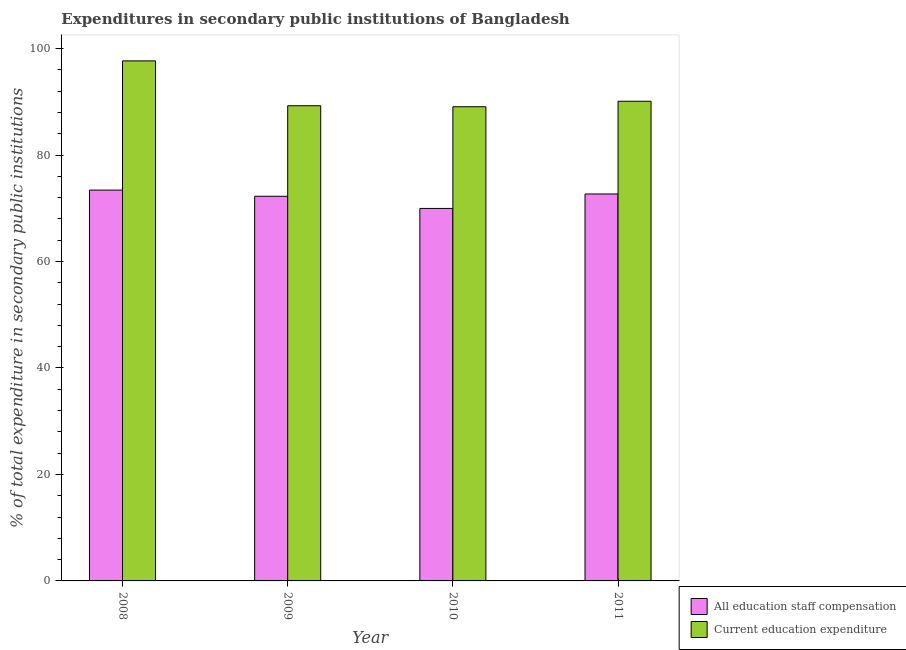Are the number of bars per tick equal to the number of legend labels?
Offer a very short reply. Yes. How many bars are there on the 2nd tick from the left?
Offer a very short reply. 2. What is the label of the 4th group of bars from the left?
Your answer should be compact. 2011. In how many cases, is the number of bars for a given year not equal to the number of legend labels?
Ensure brevity in your answer.  0. What is the expenditure in staff compensation in 2011?
Provide a short and direct response. 72.69. Across all years, what is the maximum expenditure in education?
Provide a short and direct response. 97.69. Across all years, what is the minimum expenditure in education?
Offer a very short reply. 89.08. In which year was the expenditure in staff compensation maximum?
Offer a terse response. 2008. In which year was the expenditure in staff compensation minimum?
Your answer should be very brief. 2010. What is the total expenditure in education in the graph?
Provide a succinct answer. 366.15. What is the difference between the expenditure in education in 2009 and that in 2010?
Provide a short and direct response. 0.19. What is the difference between the expenditure in education in 2010 and the expenditure in staff compensation in 2009?
Your response must be concise. -0.19. What is the average expenditure in education per year?
Offer a terse response. 91.54. In the year 2009, what is the difference between the expenditure in education and expenditure in staff compensation?
Ensure brevity in your answer.  0. What is the ratio of the expenditure in education in 2008 to that in 2011?
Keep it short and to the point. 1.08. Is the expenditure in staff compensation in 2010 less than that in 2011?
Provide a short and direct response. Yes. What is the difference between the highest and the second highest expenditure in staff compensation?
Offer a terse response. 0.73. What is the difference between the highest and the lowest expenditure in staff compensation?
Keep it short and to the point. 3.44. What does the 1st bar from the left in 2008 represents?
Provide a succinct answer. All education staff compensation. What does the 1st bar from the right in 2011 represents?
Give a very brief answer. Current education expenditure. How many bars are there?
Offer a terse response. 8. Are all the bars in the graph horizontal?
Give a very brief answer. No. How many years are there in the graph?
Provide a short and direct response. 4. What is the difference between two consecutive major ticks on the Y-axis?
Keep it short and to the point. 20. How many legend labels are there?
Keep it short and to the point. 2. What is the title of the graph?
Your answer should be very brief. Expenditures in secondary public institutions of Bangladesh. Does "From human activities" appear as one of the legend labels in the graph?
Your response must be concise. No. What is the label or title of the X-axis?
Ensure brevity in your answer.  Year. What is the label or title of the Y-axis?
Make the answer very short. % of total expenditure in secondary public institutions. What is the % of total expenditure in secondary public institutions of All education staff compensation in 2008?
Provide a short and direct response. 73.42. What is the % of total expenditure in secondary public institutions of Current education expenditure in 2008?
Offer a very short reply. 97.69. What is the % of total expenditure in secondary public institutions in All education staff compensation in 2009?
Provide a short and direct response. 72.26. What is the % of total expenditure in secondary public institutions of Current education expenditure in 2009?
Your answer should be very brief. 89.26. What is the % of total expenditure in secondary public institutions of All education staff compensation in 2010?
Offer a very short reply. 69.97. What is the % of total expenditure in secondary public institutions of Current education expenditure in 2010?
Offer a terse response. 89.08. What is the % of total expenditure in secondary public institutions of All education staff compensation in 2011?
Provide a succinct answer. 72.69. What is the % of total expenditure in secondary public institutions in Current education expenditure in 2011?
Offer a very short reply. 90.11. Across all years, what is the maximum % of total expenditure in secondary public institutions in All education staff compensation?
Provide a short and direct response. 73.42. Across all years, what is the maximum % of total expenditure in secondary public institutions of Current education expenditure?
Provide a short and direct response. 97.69. Across all years, what is the minimum % of total expenditure in secondary public institutions of All education staff compensation?
Your response must be concise. 69.97. Across all years, what is the minimum % of total expenditure in secondary public institutions in Current education expenditure?
Ensure brevity in your answer.  89.08. What is the total % of total expenditure in secondary public institutions in All education staff compensation in the graph?
Give a very brief answer. 288.34. What is the total % of total expenditure in secondary public institutions in Current education expenditure in the graph?
Give a very brief answer. 366.15. What is the difference between the % of total expenditure in secondary public institutions in All education staff compensation in 2008 and that in 2009?
Your answer should be compact. 1.16. What is the difference between the % of total expenditure in secondary public institutions of Current education expenditure in 2008 and that in 2009?
Your answer should be very brief. 8.43. What is the difference between the % of total expenditure in secondary public institutions in All education staff compensation in 2008 and that in 2010?
Offer a very short reply. 3.44. What is the difference between the % of total expenditure in secondary public institutions of Current education expenditure in 2008 and that in 2010?
Your response must be concise. 8.62. What is the difference between the % of total expenditure in secondary public institutions of All education staff compensation in 2008 and that in 2011?
Give a very brief answer. 0.73. What is the difference between the % of total expenditure in secondary public institutions of Current education expenditure in 2008 and that in 2011?
Offer a terse response. 7.58. What is the difference between the % of total expenditure in secondary public institutions of All education staff compensation in 2009 and that in 2010?
Make the answer very short. 2.29. What is the difference between the % of total expenditure in secondary public institutions of Current education expenditure in 2009 and that in 2010?
Your answer should be compact. 0.19. What is the difference between the % of total expenditure in secondary public institutions in All education staff compensation in 2009 and that in 2011?
Ensure brevity in your answer.  -0.43. What is the difference between the % of total expenditure in secondary public institutions of Current education expenditure in 2009 and that in 2011?
Your answer should be very brief. -0.84. What is the difference between the % of total expenditure in secondary public institutions in All education staff compensation in 2010 and that in 2011?
Your response must be concise. -2.72. What is the difference between the % of total expenditure in secondary public institutions in Current education expenditure in 2010 and that in 2011?
Offer a very short reply. -1.03. What is the difference between the % of total expenditure in secondary public institutions in All education staff compensation in 2008 and the % of total expenditure in secondary public institutions in Current education expenditure in 2009?
Provide a succinct answer. -15.85. What is the difference between the % of total expenditure in secondary public institutions in All education staff compensation in 2008 and the % of total expenditure in secondary public institutions in Current education expenditure in 2010?
Offer a terse response. -15.66. What is the difference between the % of total expenditure in secondary public institutions in All education staff compensation in 2008 and the % of total expenditure in secondary public institutions in Current education expenditure in 2011?
Provide a short and direct response. -16.69. What is the difference between the % of total expenditure in secondary public institutions of All education staff compensation in 2009 and the % of total expenditure in secondary public institutions of Current education expenditure in 2010?
Provide a succinct answer. -16.82. What is the difference between the % of total expenditure in secondary public institutions of All education staff compensation in 2009 and the % of total expenditure in secondary public institutions of Current education expenditure in 2011?
Ensure brevity in your answer.  -17.85. What is the difference between the % of total expenditure in secondary public institutions in All education staff compensation in 2010 and the % of total expenditure in secondary public institutions in Current education expenditure in 2011?
Offer a very short reply. -20.13. What is the average % of total expenditure in secondary public institutions of All education staff compensation per year?
Provide a succinct answer. 72.09. What is the average % of total expenditure in secondary public institutions of Current education expenditure per year?
Offer a terse response. 91.54. In the year 2008, what is the difference between the % of total expenditure in secondary public institutions in All education staff compensation and % of total expenditure in secondary public institutions in Current education expenditure?
Make the answer very short. -24.28. In the year 2009, what is the difference between the % of total expenditure in secondary public institutions of All education staff compensation and % of total expenditure in secondary public institutions of Current education expenditure?
Your answer should be compact. -17. In the year 2010, what is the difference between the % of total expenditure in secondary public institutions in All education staff compensation and % of total expenditure in secondary public institutions in Current education expenditure?
Your answer should be very brief. -19.1. In the year 2011, what is the difference between the % of total expenditure in secondary public institutions of All education staff compensation and % of total expenditure in secondary public institutions of Current education expenditure?
Offer a very short reply. -17.42. What is the ratio of the % of total expenditure in secondary public institutions in Current education expenditure in 2008 to that in 2009?
Your response must be concise. 1.09. What is the ratio of the % of total expenditure in secondary public institutions in All education staff compensation in 2008 to that in 2010?
Offer a very short reply. 1.05. What is the ratio of the % of total expenditure in secondary public institutions of Current education expenditure in 2008 to that in 2010?
Provide a succinct answer. 1.1. What is the ratio of the % of total expenditure in secondary public institutions of Current education expenditure in 2008 to that in 2011?
Make the answer very short. 1.08. What is the ratio of the % of total expenditure in secondary public institutions in All education staff compensation in 2009 to that in 2010?
Keep it short and to the point. 1.03. What is the ratio of the % of total expenditure in secondary public institutions of Current education expenditure in 2009 to that in 2011?
Keep it short and to the point. 0.99. What is the ratio of the % of total expenditure in secondary public institutions in All education staff compensation in 2010 to that in 2011?
Your answer should be very brief. 0.96. What is the difference between the highest and the second highest % of total expenditure in secondary public institutions of All education staff compensation?
Keep it short and to the point. 0.73. What is the difference between the highest and the second highest % of total expenditure in secondary public institutions of Current education expenditure?
Provide a short and direct response. 7.58. What is the difference between the highest and the lowest % of total expenditure in secondary public institutions of All education staff compensation?
Your response must be concise. 3.44. What is the difference between the highest and the lowest % of total expenditure in secondary public institutions in Current education expenditure?
Give a very brief answer. 8.62. 